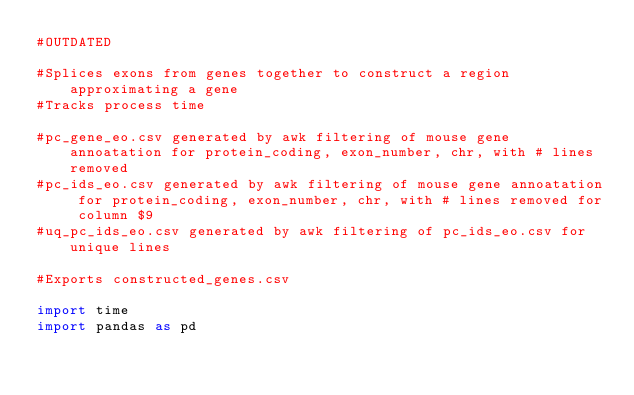Convert code to text. <code><loc_0><loc_0><loc_500><loc_500><_Python_>#OUTDATED

#Splices exons from genes together to construct a region approximating a gene
#Tracks process time

#pc_gene_eo.csv generated by awk filtering of mouse gene annoatation for protein_coding, exon_number, chr, with # lines removed
#pc_ids_eo.csv generated by awk filtering of mouse gene annoatation for protein_coding, exon_number, chr, with # lines removed for column $9
#uq_pc_ids_eo.csv generated by awk filtering of pc_ids_eo.csv for unique lines

#Exports constructed_genes.csv

import time
import pandas as pd 
</code> 